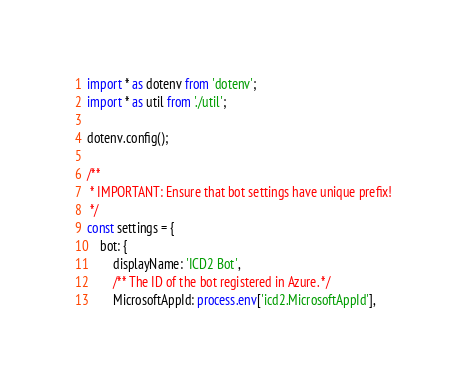<code> <loc_0><loc_0><loc_500><loc_500><_TypeScript_>import * as dotenv from 'dotenv';
import * as util from './util';

dotenv.config();

/**
 * IMPORTANT: Ensure that bot settings have unique prefix!
 */
const settings = {
    bot: {
        displayName: 'ICD2 Bot',
        /** The ID of the bot registered in Azure. */
        MicrosoftAppId: process.env['icd2.MicrosoftAppId'],</code> 